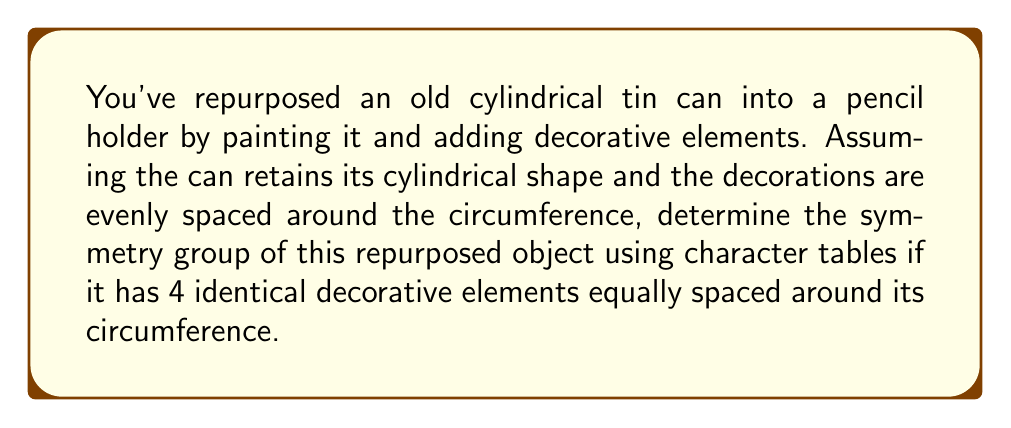Solve this math problem. Let's approach this step-by-step:

1) First, we need to identify the symmetries of the object:
   - Rotational symmetry: The can can be rotated by 90°, 180°, 270°, and 360° (identity).
   - Reflection symmetry: There are 4 vertical planes of reflection.
   - The object also has horizontal reflection symmetry (top to bottom).

2) This combination of symmetries corresponds to the dihedral group $D_4$ (also known as $D_8$ in some notations).

3) The character table for $D_4$ is as follows:

   $$
   \begin{array}{c|ccccc}
    D_4 & E & C_4 & C_2 & 2C_2' & 2\sigma_v \\
   \hline
   A_1 & 1 & 1 & 1 & 1 & 1 \\
   A_2 & 1 & 1 & 1 & -1 & -1 \\
   B_1 & 1 & -1 & 1 & 1 & -1 \\
   B_2 & 1 & -1 & 1 & -1 & 1 \\
   E & 2 & 0 & -2 & 0 & 0
   \end{array}
   $$

   Where:
   - $E$ is the identity operation
   - $C_4$ is rotation by 90°
   - $C_2$ is rotation by 180°
   - $2C_2'$ represents the two diagonal reflection planes
   - $2\sigma_v$ represents the two vertical reflection planes (front-back and left-right)

4) To confirm this is the correct symmetry group, we can check that all the symmetry operations of our repurposed can are represented in this character table.

5) The repurposed can has:
   - 1 identity operation (E)
   - 2 rotations by 90° ($C_4$ and $C_4^3$)
   - 1 rotation by 180° ($C_2$)
   - 2 diagonal reflections ($2C_2'$)
   - 2 vertical reflections ($2\sigma_v$)
   - 1 horizontal reflection (which combines with the rotations to give the other elements)

This matches the structure of $D_4$, confirming it as the symmetry group of the repurposed object.
Answer: $D_4$ 